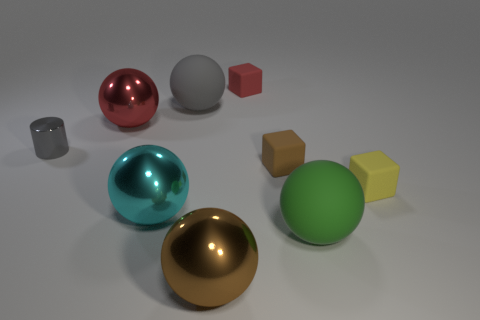Subtract 3 balls. How many balls are left? 2 Subtract all cyan balls. How many balls are left? 4 Subtract all brown spheres. How many spheres are left? 4 Subtract all red balls. Subtract all brown cylinders. How many balls are left? 4 Subtract all cylinders. How many objects are left? 8 Subtract 0 yellow cylinders. How many objects are left? 9 Subtract all cyan metallic blocks. Subtract all green objects. How many objects are left? 8 Add 3 red metallic things. How many red metallic things are left? 4 Add 8 purple rubber cylinders. How many purple rubber cylinders exist? 8 